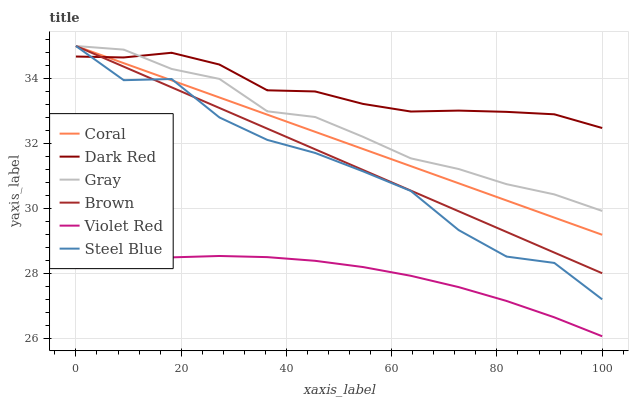Does Violet Red have the minimum area under the curve?
Answer yes or no. Yes. Does Dark Red have the maximum area under the curve?
Answer yes or no. Yes. Does Gray have the minimum area under the curve?
Answer yes or no. No. Does Gray have the maximum area under the curve?
Answer yes or no. No. Is Coral the smoothest?
Answer yes or no. Yes. Is Steel Blue the roughest?
Answer yes or no. Yes. Is Violet Red the smoothest?
Answer yes or no. No. Is Violet Red the roughest?
Answer yes or no. No. Does Gray have the lowest value?
Answer yes or no. No. Does Steel Blue have the highest value?
Answer yes or no. Yes. Does Violet Red have the highest value?
Answer yes or no. No. Is Violet Red less than Gray?
Answer yes or no. Yes. Is Coral greater than Violet Red?
Answer yes or no. Yes. Does Steel Blue intersect Brown?
Answer yes or no. Yes. Is Steel Blue less than Brown?
Answer yes or no. No. Is Steel Blue greater than Brown?
Answer yes or no. No. Does Violet Red intersect Gray?
Answer yes or no. No. 